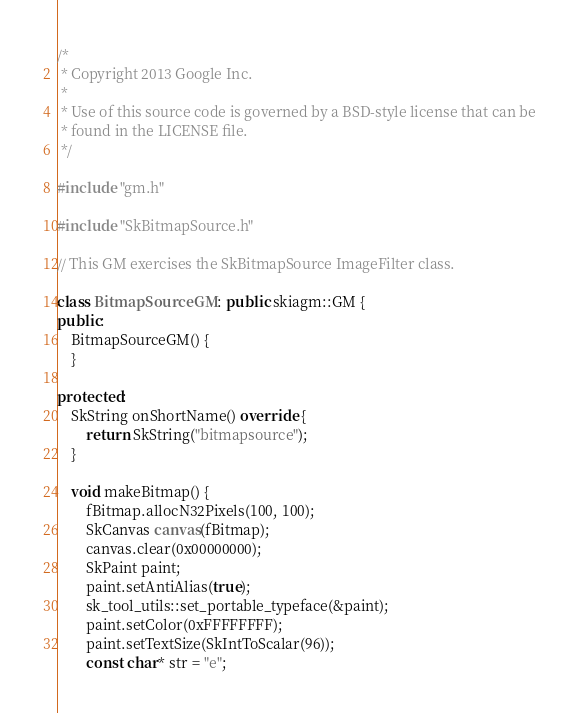<code> <loc_0><loc_0><loc_500><loc_500><_C++_>/*
 * Copyright 2013 Google Inc.
 *
 * Use of this source code is governed by a BSD-style license that can be
 * found in the LICENSE file.
 */

#include "gm.h"

#include "SkBitmapSource.h"

// This GM exercises the SkBitmapSource ImageFilter class.

class BitmapSourceGM : public skiagm::GM {
public:
    BitmapSourceGM() {
    }

protected:
    SkString onShortName() override {
        return SkString("bitmapsource");
    }

    void makeBitmap() {
        fBitmap.allocN32Pixels(100, 100);
        SkCanvas canvas(fBitmap);
        canvas.clear(0x00000000);
        SkPaint paint;
        paint.setAntiAlias(true);
        sk_tool_utils::set_portable_typeface(&paint);
        paint.setColor(0xFFFFFFFF);
        paint.setTextSize(SkIntToScalar(96));
        const char* str = "e";</code> 